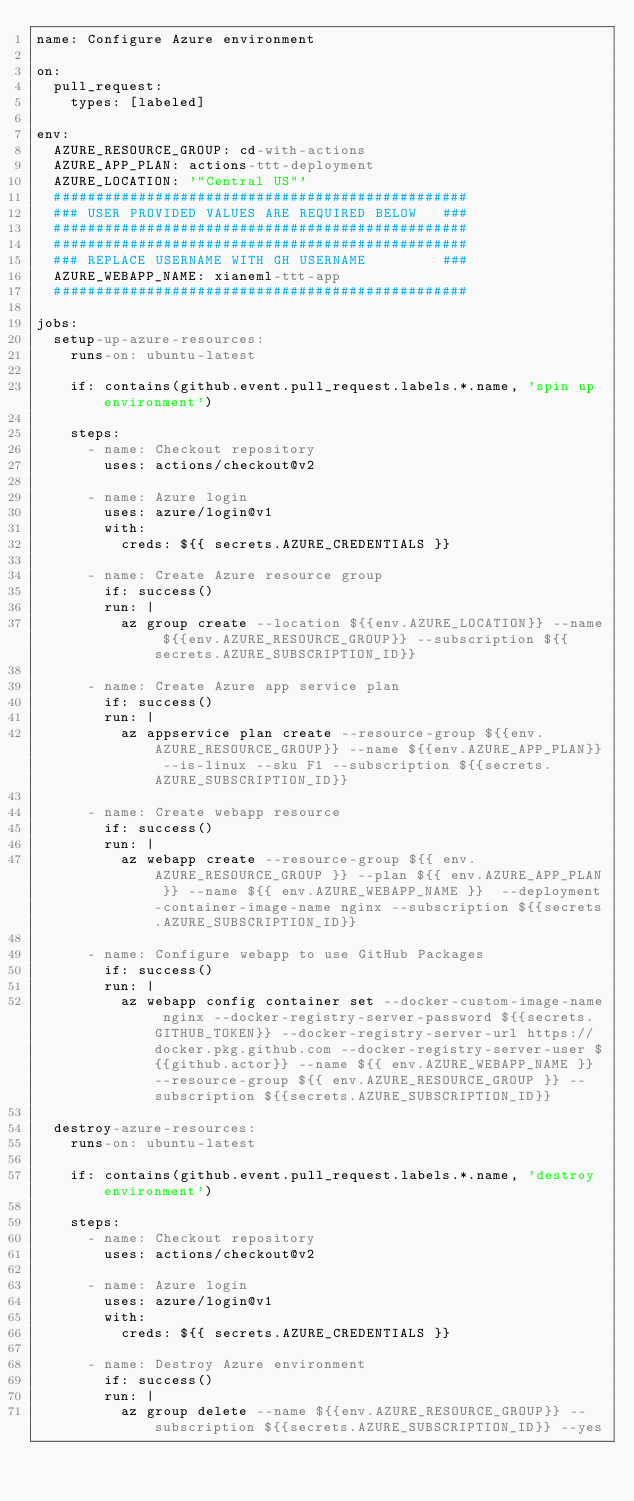<code> <loc_0><loc_0><loc_500><loc_500><_YAML_>name: Configure Azure environment

on: 
  pull_request:
    types: [labeled]

env:
  AZURE_RESOURCE_GROUP: cd-with-actions
  AZURE_APP_PLAN: actions-ttt-deployment
  AZURE_LOCATION: '"Central US"'
  #################################################
  ### USER PROVIDED VALUES ARE REQUIRED BELOW   ###
  #################################################
  #################################################
  ### REPLACE USERNAME WITH GH USERNAME         ###
  AZURE_WEBAPP_NAME: xianeml-ttt-app
  #################################################

jobs:
  setup-up-azure-resources:
    runs-on: ubuntu-latest

    if: contains(github.event.pull_request.labels.*.name, 'spin up environment')

    steps:
      - name: Checkout repository
        uses: actions/checkout@v2

      - name: Azure login
        uses: azure/login@v1
        with:
          creds: ${{ secrets.AZURE_CREDENTIALS }}

      - name: Create Azure resource group
        if: success()
        run: |
          az group create --location ${{env.AZURE_LOCATION}} --name ${{env.AZURE_RESOURCE_GROUP}} --subscription ${{secrets.AZURE_SUBSCRIPTION_ID}}

      - name: Create Azure app service plan
        if: success()
        run: |
          az appservice plan create --resource-group ${{env.AZURE_RESOURCE_GROUP}} --name ${{env.AZURE_APP_PLAN}} --is-linux --sku F1 --subscription ${{secrets.AZURE_SUBSCRIPTION_ID}}

      - name: Create webapp resource
        if: success()
        run: |
          az webapp create --resource-group ${{ env.AZURE_RESOURCE_GROUP }} --plan ${{ env.AZURE_APP_PLAN }} --name ${{ env.AZURE_WEBAPP_NAME }}  --deployment-container-image-name nginx --subscription ${{secrets.AZURE_SUBSCRIPTION_ID}}

      - name: Configure webapp to use GitHub Packages
        if: success()
        run: |
          az webapp config container set --docker-custom-image-name nginx --docker-registry-server-password ${{secrets.GITHUB_TOKEN}} --docker-registry-server-url https://docker.pkg.github.com --docker-registry-server-user ${{github.actor}} --name ${{ env.AZURE_WEBAPP_NAME }} --resource-group ${{ env.AZURE_RESOURCE_GROUP }} --subscription ${{secrets.AZURE_SUBSCRIPTION_ID}}

  destroy-azure-resources:
    runs-on: ubuntu-latest

    if: contains(github.event.pull_request.labels.*.name, 'destroy environment')

    steps:
      - name: Checkout repository
        uses: actions/checkout@v2

      - name: Azure login
        uses: azure/login@v1
        with:
          creds: ${{ secrets.AZURE_CREDENTIALS }}

      - name: Destroy Azure environment
        if: success()
        run: |
          az group delete --name ${{env.AZURE_RESOURCE_GROUP}} --subscription ${{secrets.AZURE_SUBSCRIPTION_ID}} --yes
</code> 